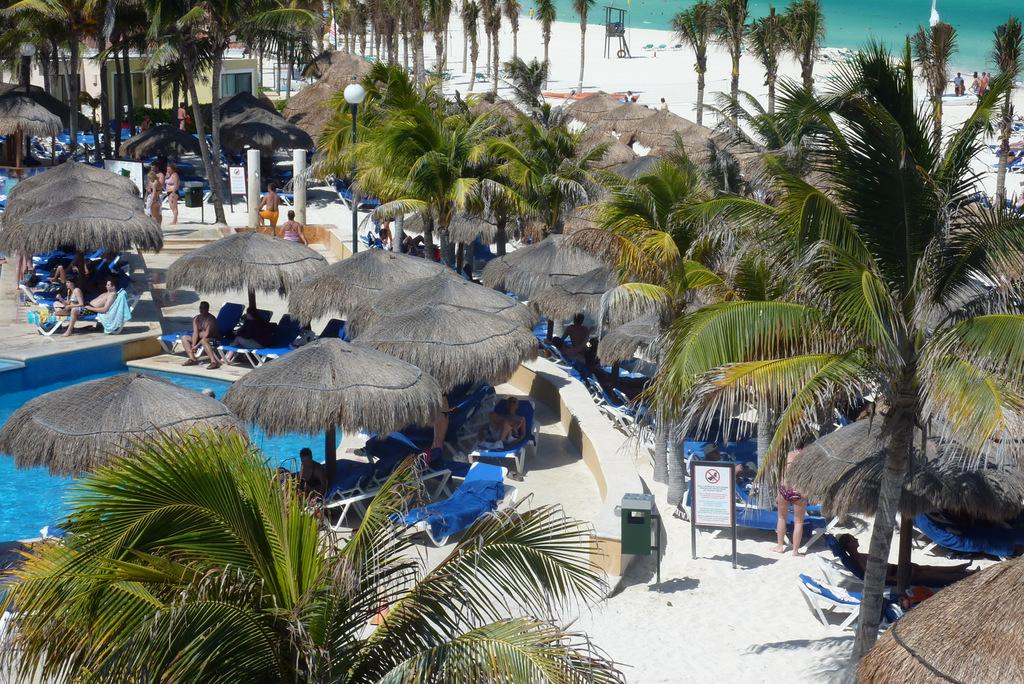How many people are in the image? There are few persons in the image. What type of vegetation is present in the image? There are trees in the image. What objects are used for protection from the sun or rain in the image? There are umbrellas in the image. What is used for relaxation in the image? There are hammocks in the image. What natural element is visible in the image? There is water visible in the image. What structures are present in the image for support or stability? There are poles in the image. What source of illumination is present in the image? There is light in the image. What objects are used for displaying information or messages in the image? There are boards in the image. What type of building is present in the image? There is a house in the image. What type of fowl can be seen swimming in the ocean in the image? There is no fowl or ocean present in the image. What type of can is visible in the image? There is no can present in the image. 